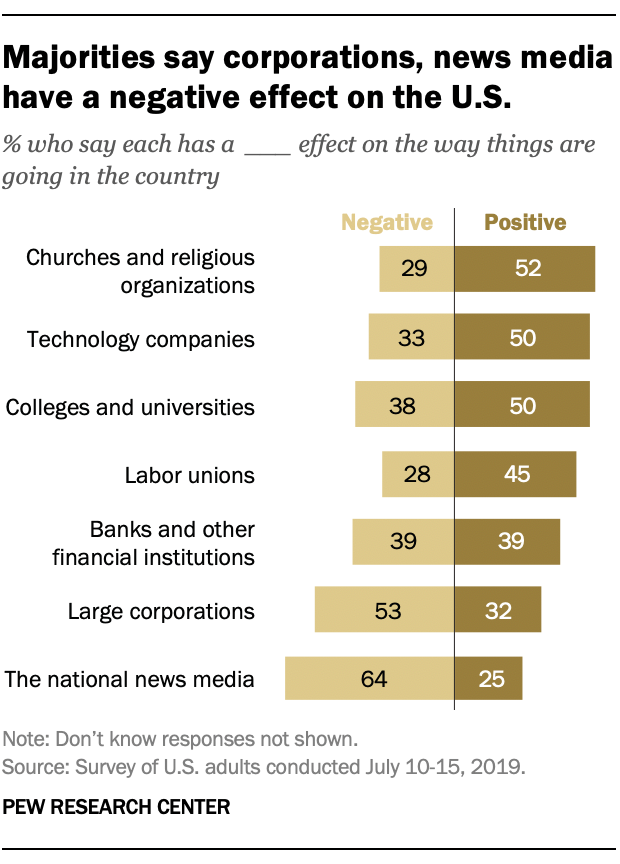Specify some key components in this picture. The two aspects used in this graph are negative and positive. The median value of the "Negative" bars is 38. 